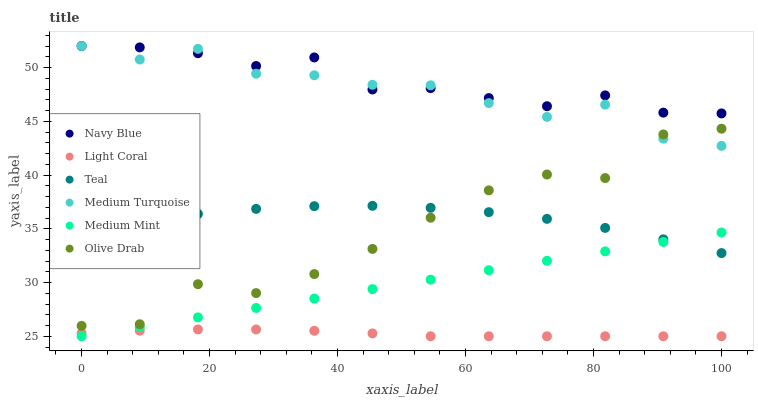Does Light Coral have the minimum area under the curve?
Answer yes or no. Yes. Does Navy Blue have the maximum area under the curve?
Answer yes or no. Yes. Does Teal have the minimum area under the curve?
Answer yes or no. No. Does Teal have the maximum area under the curve?
Answer yes or no. No. Is Medium Mint the smoothest?
Answer yes or no. Yes. Is Olive Drab the roughest?
Answer yes or no. Yes. Is Teal the smoothest?
Answer yes or no. No. Is Teal the roughest?
Answer yes or no. No. Does Medium Mint have the lowest value?
Answer yes or no. Yes. Does Teal have the lowest value?
Answer yes or no. No. Does Medium Turquoise have the highest value?
Answer yes or no. Yes. Does Teal have the highest value?
Answer yes or no. No. Is Medium Mint less than Olive Drab?
Answer yes or no. Yes. Is Olive Drab greater than Medium Mint?
Answer yes or no. Yes. Does Navy Blue intersect Medium Turquoise?
Answer yes or no. Yes. Is Navy Blue less than Medium Turquoise?
Answer yes or no. No. Is Navy Blue greater than Medium Turquoise?
Answer yes or no. No. Does Medium Mint intersect Olive Drab?
Answer yes or no. No. 